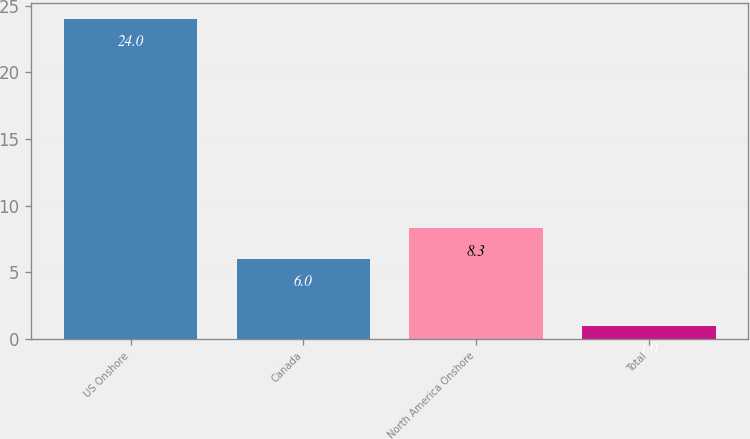Convert chart. <chart><loc_0><loc_0><loc_500><loc_500><bar_chart><fcel>US Onshore<fcel>Canada<fcel>North America Onshore<fcel>Total<nl><fcel>24<fcel>6<fcel>8.3<fcel>1<nl></chart> 